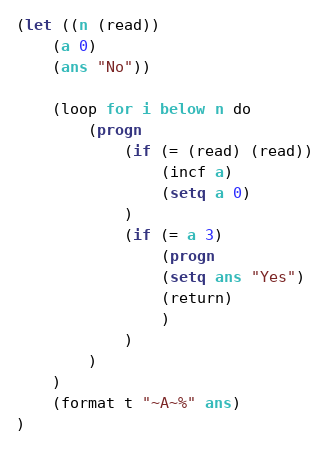Convert code to text. <code><loc_0><loc_0><loc_500><loc_500><_Lisp_>(let ((n (read))
    (a 0)
    (ans "No"))

    (loop for i below n do
        (progn
            (if (= (read) (read))
                (incf a)
                (setq a 0)
            )
            (if (= a 3)
                (progn
                (setq ans "Yes")
                (return)
                )
            )
        )
    )
    (format t "~A~%" ans)
)</code> 